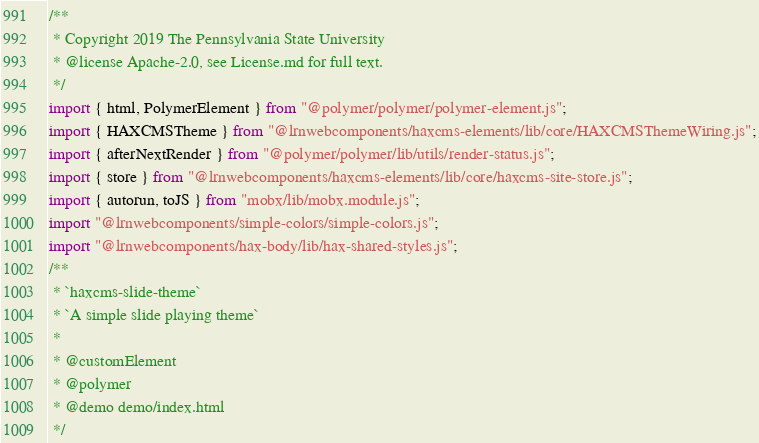Convert code to text. <code><loc_0><loc_0><loc_500><loc_500><_JavaScript_>/**
 * Copyright 2019 The Pennsylvania State University
 * @license Apache-2.0, see License.md for full text.
 */
import { html, PolymerElement } from "@polymer/polymer/polymer-element.js";
import { HAXCMSTheme } from "@lrnwebcomponents/haxcms-elements/lib/core/HAXCMSThemeWiring.js";
import { afterNextRender } from "@polymer/polymer/lib/utils/render-status.js";
import { store } from "@lrnwebcomponents/haxcms-elements/lib/core/haxcms-site-store.js";
import { autorun, toJS } from "mobx/lib/mobx.module.js";
import "@lrnwebcomponents/simple-colors/simple-colors.js";
import "@lrnwebcomponents/hax-body/lib/hax-shared-styles.js";
/**
 * `haxcms-slide-theme`
 * `A simple slide playing theme`
 *
 * @customElement
 * @polymer
 * @demo demo/index.html
 */</code> 